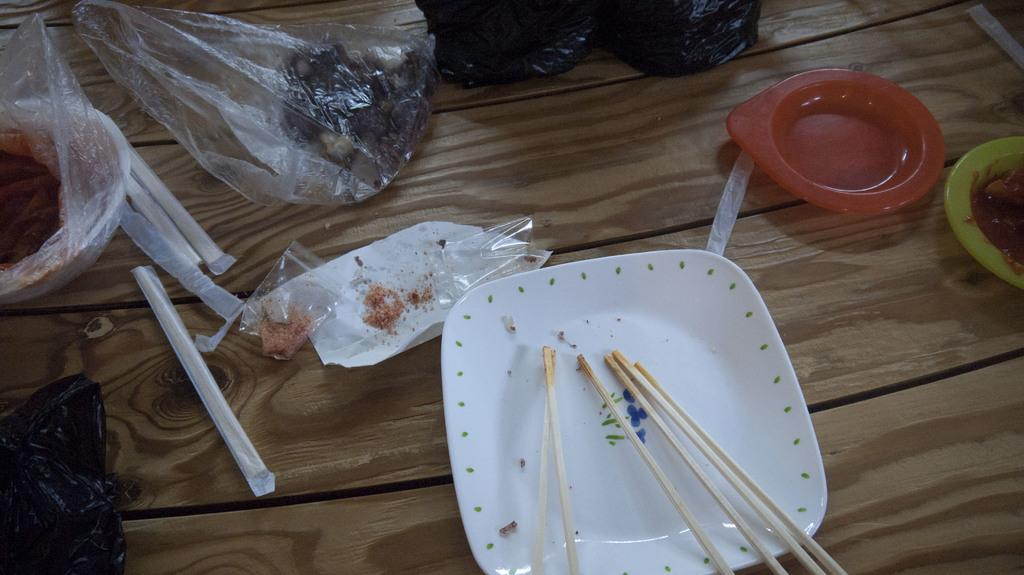What piece of furniture is visible in the image? There is a table in the image. What items are placed on the table? There are plates, toothpicks, packets, and a bowl containing chilli powder on the table. What might be used for picking up small pieces of food in the image? Toothpicks are present on the table for picking up small pieces of food. What type of condiment is in the bowl on the table? The bowl on the table contains chilli powder. How does the table handle the rainstorm in the image? There is no rainstorm present in the image, and therefore the table is not handling any rain. What type of utensil is used for eating salad in the image? There is no salad or fork present in the image, so it is not possible to determine what type of utensil might be used for eating salad. 